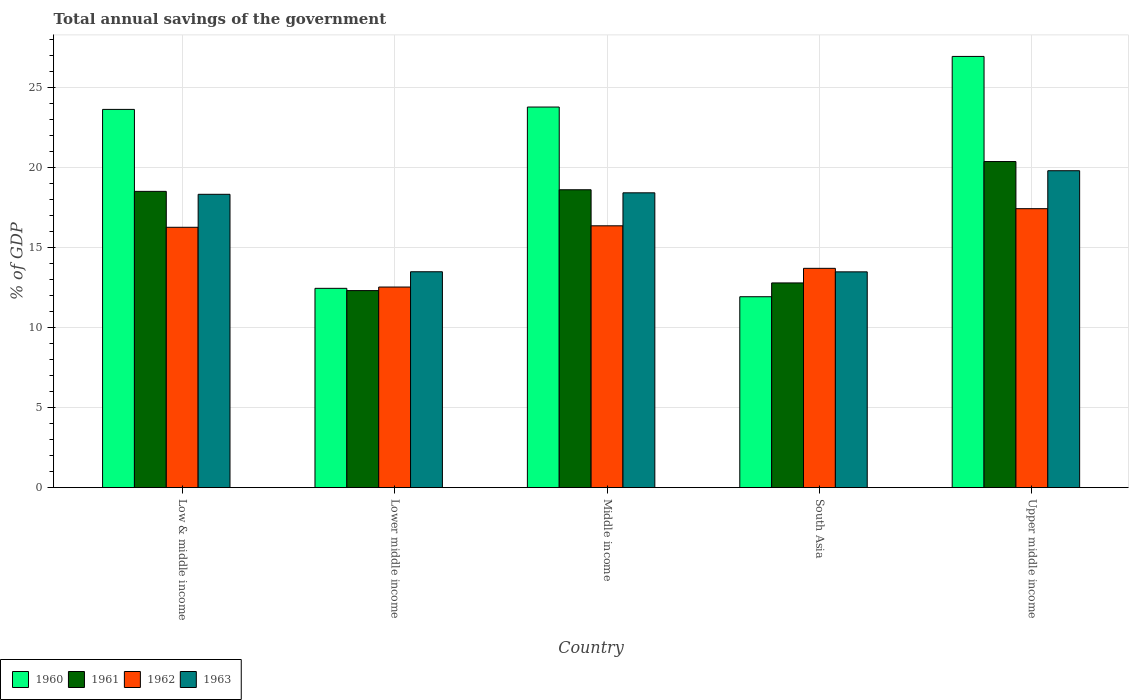How many different coloured bars are there?
Make the answer very short. 4. How many groups of bars are there?
Your response must be concise. 5. How many bars are there on the 4th tick from the left?
Make the answer very short. 4. How many bars are there on the 1st tick from the right?
Keep it short and to the point. 4. What is the label of the 3rd group of bars from the left?
Your response must be concise. Middle income. In how many cases, is the number of bars for a given country not equal to the number of legend labels?
Keep it short and to the point. 0. What is the total annual savings of the government in 1962 in Lower middle income?
Offer a very short reply. 12.53. Across all countries, what is the maximum total annual savings of the government in 1961?
Provide a short and direct response. 20.37. Across all countries, what is the minimum total annual savings of the government in 1961?
Offer a terse response. 12.3. In which country was the total annual savings of the government in 1962 maximum?
Your answer should be compact. Upper middle income. What is the total total annual savings of the government in 1962 in the graph?
Your answer should be compact. 76.25. What is the difference between the total annual savings of the government in 1960 in Low & middle income and that in South Asia?
Your answer should be very brief. 11.7. What is the difference between the total annual savings of the government in 1963 in South Asia and the total annual savings of the government in 1960 in Middle income?
Keep it short and to the point. -10.29. What is the average total annual savings of the government in 1960 per country?
Ensure brevity in your answer.  19.74. What is the difference between the total annual savings of the government of/in 1961 and total annual savings of the government of/in 1963 in Low & middle income?
Make the answer very short. 0.18. What is the ratio of the total annual savings of the government in 1962 in Middle income to that in Upper middle income?
Give a very brief answer. 0.94. Is the difference between the total annual savings of the government in 1961 in Lower middle income and Upper middle income greater than the difference between the total annual savings of the government in 1963 in Lower middle income and Upper middle income?
Give a very brief answer. No. What is the difference between the highest and the second highest total annual savings of the government in 1962?
Make the answer very short. -1.07. What is the difference between the highest and the lowest total annual savings of the government in 1962?
Offer a terse response. 4.89. In how many countries, is the total annual savings of the government in 1960 greater than the average total annual savings of the government in 1960 taken over all countries?
Your answer should be compact. 3. Is the sum of the total annual savings of the government in 1961 in Low & middle income and Upper middle income greater than the maximum total annual savings of the government in 1960 across all countries?
Your response must be concise. Yes. What does the 4th bar from the left in Low & middle income represents?
Provide a succinct answer. 1963. Is it the case that in every country, the sum of the total annual savings of the government in 1960 and total annual savings of the government in 1963 is greater than the total annual savings of the government in 1961?
Ensure brevity in your answer.  Yes. Are all the bars in the graph horizontal?
Your answer should be compact. No. Does the graph contain any zero values?
Keep it short and to the point. No. Does the graph contain grids?
Offer a terse response. Yes. What is the title of the graph?
Provide a succinct answer. Total annual savings of the government. Does "2011" appear as one of the legend labels in the graph?
Provide a succinct answer. No. What is the label or title of the X-axis?
Keep it short and to the point. Country. What is the label or title of the Y-axis?
Your answer should be compact. % of GDP. What is the % of GDP of 1960 in Low & middle income?
Give a very brief answer. 23.62. What is the % of GDP in 1961 in Low & middle income?
Your answer should be very brief. 18.5. What is the % of GDP in 1962 in Low & middle income?
Keep it short and to the point. 16.26. What is the % of GDP in 1963 in Low & middle income?
Your answer should be compact. 18.32. What is the % of GDP of 1960 in Lower middle income?
Ensure brevity in your answer.  12.45. What is the % of GDP in 1961 in Lower middle income?
Ensure brevity in your answer.  12.3. What is the % of GDP in 1962 in Lower middle income?
Keep it short and to the point. 12.53. What is the % of GDP of 1963 in Lower middle income?
Your response must be concise. 13.48. What is the % of GDP in 1960 in Middle income?
Ensure brevity in your answer.  23.77. What is the % of GDP in 1961 in Middle income?
Provide a short and direct response. 18.6. What is the % of GDP of 1962 in Middle income?
Give a very brief answer. 16.35. What is the % of GDP in 1963 in Middle income?
Provide a short and direct response. 18.41. What is the % of GDP in 1960 in South Asia?
Your answer should be compact. 11.92. What is the % of GDP of 1961 in South Asia?
Provide a short and direct response. 12.78. What is the % of GDP in 1962 in South Asia?
Keep it short and to the point. 13.69. What is the % of GDP of 1963 in South Asia?
Your response must be concise. 13.48. What is the % of GDP of 1960 in Upper middle income?
Ensure brevity in your answer.  26.93. What is the % of GDP in 1961 in Upper middle income?
Offer a very short reply. 20.37. What is the % of GDP of 1962 in Upper middle income?
Your answer should be very brief. 17.42. What is the % of GDP of 1963 in Upper middle income?
Provide a short and direct response. 19.79. Across all countries, what is the maximum % of GDP in 1960?
Your answer should be very brief. 26.93. Across all countries, what is the maximum % of GDP of 1961?
Provide a succinct answer. 20.37. Across all countries, what is the maximum % of GDP in 1962?
Provide a succinct answer. 17.42. Across all countries, what is the maximum % of GDP of 1963?
Offer a very short reply. 19.79. Across all countries, what is the minimum % of GDP in 1960?
Ensure brevity in your answer.  11.92. Across all countries, what is the minimum % of GDP of 1961?
Offer a terse response. 12.3. Across all countries, what is the minimum % of GDP of 1962?
Offer a terse response. 12.53. Across all countries, what is the minimum % of GDP of 1963?
Give a very brief answer. 13.48. What is the total % of GDP of 1960 in the graph?
Offer a terse response. 98.69. What is the total % of GDP of 1961 in the graph?
Give a very brief answer. 82.56. What is the total % of GDP in 1962 in the graph?
Offer a terse response. 76.25. What is the total % of GDP in 1963 in the graph?
Give a very brief answer. 83.48. What is the difference between the % of GDP in 1960 in Low & middle income and that in Lower middle income?
Offer a very short reply. 11.18. What is the difference between the % of GDP in 1961 in Low & middle income and that in Lower middle income?
Ensure brevity in your answer.  6.2. What is the difference between the % of GDP in 1962 in Low & middle income and that in Lower middle income?
Your answer should be very brief. 3.73. What is the difference between the % of GDP in 1963 in Low & middle income and that in Lower middle income?
Your response must be concise. 4.84. What is the difference between the % of GDP of 1960 in Low & middle income and that in Middle income?
Your answer should be very brief. -0.15. What is the difference between the % of GDP in 1961 in Low & middle income and that in Middle income?
Your response must be concise. -0.1. What is the difference between the % of GDP of 1962 in Low & middle income and that in Middle income?
Ensure brevity in your answer.  -0.09. What is the difference between the % of GDP of 1963 in Low & middle income and that in Middle income?
Ensure brevity in your answer.  -0.09. What is the difference between the % of GDP in 1960 in Low & middle income and that in South Asia?
Make the answer very short. 11.7. What is the difference between the % of GDP of 1961 in Low & middle income and that in South Asia?
Offer a very short reply. 5.72. What is the difference between the % of GDP in 1962 in Low & middle income and that in South Asia?
Give a very brief answer. 2.56. What is the difference between the % of GDP of 1963 in Low & middle income and that in South Asia?
Your response must be concise. 4.84. What is the difference between the % of GDP of 1960 in Low & middle income and that in Upper middle income?
Your answer should be very brief. -3.31. What is the difference between the % of GDP in 1961 in Low & middle income and that in Upper middle income?
Give a very brief answer. -1.86. What is the difference between the % of GDP of 1962 in Low & middle income and that in Upper middle income?
Keep it short and to the point. -1.16. What is the difference between the % of GDP in 1963 in Low & middle income and that in Upper middle income?
Ensure brevity in your answer.  -1.47. What is the difference between the % of GDP in 1960 in Lower middle income and that in Middle income?
Offer a very short reply. -11.32. What is the difference between the % of GDP of 1961 in Lower middle income and that in Middle income?
Give a very brief answer. -6.3. What is the difference between the % of GDP in 1962 in Lower middle income and that in Middle income?
Your response must be concise. -3.82. What is the difference between the % of GDP of 1963 in Lower middle income and that in Middle income?
Offer a very short reply. -4.93. What is the difference between the % of GDP of 1960 in Lower middle income and that in South Asia?
Your response must be concise. 0.52. What is the difference between the % of GDP in 1961 in Lower middle income and that in South Asia?
Provide a succinct answer. -0.48. What is the difference between the % of GDP of 1962 in Lower middle income and that in South Asia?
Provide a short and direct response. -1.17. What is the difference between the % of GDP in 1963 in Lower middle income and that in South Asia?
Keep it short and to the point. 0.01. What is the difference between the % of GDP of 1960 in Lower middle income and that in Upper middle income?
Ensure brevity in your answer.  -14.48. What is the difference between the % of GDP of 1961 in Lower middle income and that in Upper middle income?
Give a very brief answer. -8.06. What is the difference between the % of GDP in 1962 in Lower middle income and that in Upper middle income?
Make the answer very short. -4.89. What is the difference between the % of GDP in 1963 in Lower middle income and that in Upper middle income?
Make the answer very short. -6.31. What is the difference between the % of GDP in 1960 in Middle income and that in South Asia?
Offer a terse response. 11.85. What is the difference between the % of GDP in 1961 in Middle income and that in South Asia?
Provide a short and direct response. 5.82. What is the difference between the % of GDP of 1962 in Middle income and that in South Asia?
Keep it short and to the point. 2.66. What is the difference between the % of GDP of 1963 in Middle income and that in South Asia?
Ensure brevity in your answer.  4.94. What is the difference between the % of GDP of 1960 in Middle income and that in Upper middle income?
Keep it short and to the point. -3.16. What is the difference between the % of GDP of 1961 in Middle income and that in Upper middle income?
Your answer should be compact. -1.76. What is the difference between the % of GDP in 1962 in Middle income and that in Upper middle income?
Provide a succinct answer. -1.07. What is the difference between the % of GDP in 1963 in Middle income and that in Upper middle income?
Provide a short and direct response. -1.38. What is the difference between the % of GDP in 1960 in South Asia and that in Upper middle income?
Your answer should be very brief. -15.01. What is the difference between the % of GDP of 1961 in South Asia and that in Upper middle income?
Provide a succinct answer. -7.58. What is the difference between the % of GDP in 1962 in South Asia and that in Upper middle income?
Keep it short and to the point. -3.73. What is the difference between the % of GDP in 1963 in South Asia and that in Upper middle income?
Offer a very short reply. -6.32. What is the difference between the % of GDP of 1960 in Low & middle income and the % of GDP of 1961 in Lower middle income?
Your answer should be very brief. 11.32. What is the difference between the % of GDP of 1960 in Low & middle income and the % of GDP of 1962 in Lower middle income?
Provide a short and direct response. 11.09. What is the difference between the % of GDP of 1960 in Low & middle income and the % of GDP of 1963 in Lower middle income?
Keep it short and to the point. 10.14. What is the difference between the % of GDP in 1961 in Low & middle income and the % of GDP in 1962 in Lower middle income?
Provide a succinct answer. 5.97. What is the difference between the % of GDP in 1961 in Low & middle income and the % of GDP in 1963 in Lower middle income?
Make the answer very short. 5.02. What is the difference between the % of GDP of 1962 in Low & middle income and the % of GDP of 1963 in Lower middle income?
Provide a short and direct response. 2.78. What is the difference between the % of GDP of 1960 in Low & middle income and the % of GDP of 1961 in Middle income?
Make the answer very short. 5.02. What is the difference between the % of GDP in 1960 in Low & middle income and the % of GDP in 1962 in Middle income?
Your answer should be very brief. 7.27. What is the difference between the % of GDP of 1960 in Low & middle income and the % of GDP of 1963 in Middle income?
Provide a short and direct response. 5.21. What is the difference between the % of GDP of 1961 in Low & middle income and the % of GDP of 1962 in Middle income?
Ensure brevity in your answer.  2.15. What is the difference between the % of GDP of 1961 in Low & middle income and the % of GDP of 1963 in Middle income?
Give a very brief answer. 0.09. What is the difference between the % of GDP in 1962 in Low & middle income and the % of GDP in 1963 in Middle income?
Your answer should be compact. -2.15. What is the difference between the % of GDP in 1960 in Low & middle income and the % of GDP in 1961 in South Asia?
Your response must be concise. 10.84. What is the difference between the % of GDP of 1960 in Low & middle income and the % of GDP of 1962 in South Asia?
Your answer should be compact. 9.93. What is the difference between the % of GDP in 1960 in Low & middle income and the % of GDP in 1963 in South Asia?
Your answer should be compact. 10.15. What is the difference between the % of GDP of 1961 in Low & middle income and the % of GDP of 1962 in South Asia?
Your response must be concise. 4.81. What is the difference between the % of GDP of 1961 in Low & middle income and the % of GDP of 1963 in South Asia?
Your answer should be very brief. 5.03. What is the difference between the % of GDP in 1962 in Low & middle income and the % of GDP in 1963 in South Asia?
Your answer should be compact. 2.78. What is the difference between the % of GDP of 1960 in Low & middle income and the % of GDP of 1961 in Upper middle income?
Your answer should be compact. 3.26. What is the difference between the % of GDP in 1960 in Low & middle income and the % of GDP in 1962 in Upper middle income?
Make the answer very short. 6.2. What is the difference between the % of GDP of 1960 in Low & middle income and the % of GDP of 1963 in Upper middle income?
Your answer should be very brief. 3.83. What is the difference between the % of GDP of 1961 in Low & middle income and the % of GDP of 1962 in Upper middle income?
Give a very brief answer. 1.08. What is the difference between the % of GDP in 1961 in Low & middle income and the % of GDP in 1963 in Upper middle income?
Provide a short and direct response. -1.29. What is the difference between the % of GDP in 1962 in Low & middle income and the % of GDP in 1963 in Upper middle income?
Ensure brevity in your answer.  -3.53. What is the difference between the % of GDP of 1960 in Lower middle income and the % of GDP of 1961 in Middle income?
Provide a succinct answer. -6.16. What is the difference between the % of GDP in 1960 in Lower middle income and the % of GDP in 1962 in Middle income?
Keep it short and to the point. -3.9. What is the difference between the % of GDP in 1960 in Lower middle income and the % of GDP in 1963 in Middle income?
Your answer should be very brief. -5.97. What is the difference between the % of GDP of 1961 in Lower middle income and the % of GDP of 1962 in Middle income?
Keep it short and to the point. -4.05. What is the difference between the % of GDP in 1961 in Lower middle income and the % of GDP in 1963 in Middle income?
Your answer should be very brief. -6.11. What is the difference between the % of GDP in 1962 in Lower middle income and the % of GDP in 1963 in Middle income?
Keep it short and to the point. -5.88. What is the difference between the % of GDP of 1960 in Lower middle income and the % of GDP of 1961 in South Asia?
Provide a short and direct response. -0.34. What is the difference between the % of GDP in 1960 in Lower middle income and the % of GDP in 1962 in South Asia?
Ensure brevity in your answer.  -1.25. What is the difference between the % of GDP of 1960 in Lower middle income and the % of GDP of 1963 in South Asia?
Provide a succinct answer. -1.03. What is the difference between the % of GDP of 1961 in Lower middle income and the % of GDP of 1962 in South Asia?
Provide a short and direct response. -1.39. What is the difference between the % of GDP of 1961 in Lower middle income and the % of GDP of 1963 in South Asia?
Give a very brief answer. -1.17. What is the difference between the % of GDP in 1962 in Lower middle income and the % of GDP in 1963 in South Asia?
Offer a very short reply. -0.95. What is the difference between the % of GDP of 1960 in Lower middle income and the % of GDP of 1961 in Upper middle income?
Provide a short and direct response. -7.92. What is the difference between the % of GDP of 1960 in Lower middle income and the % of GDP of 1962 in Upper middle income?
Offer a very short reply. -4.98. What is the difference between the % of GDP in 1960 in Lower middle income and the % of GDP in 1963 in Upper middle income?
Offer a very short reply. -7.35. What is the difference between the % of GDP in 1961 in Lower middle income and the % of GDP in 1962 in Upper middle income?
Give a very brief answer. -5.12. What is the difference between the % of GDP in 1961 in Lower middle income and the % of GDP in 1963 in Upper middle income?
Make the answer very short. -7.49. What is the difference between the % of GDP of 1962 in Lower middle income and the % of GDP of 1963 in Upper middle income?
Make the answer very short. -7.26. What is the difference between the % of GDP in 1960 in Middle income and the % of GDP in 1961 in South Asia?
Provide a succinct answer. 10.98. What is the difference between the % of GDP in 1960 in Middle income and the % of GDP in 1962 in South Asia?
Your answer should be very brief. 10.07. What is the difference between the % of GDP of 1960 in Middle income and the % of GDP of 1963 in South Asia?
Make the answer very short. 10.29. What is the difference between the % of GDP in 1961 in Middle income and the % of GDP in 1962 in South Asia?
Keep it short and to the point. 4.91. What is the difference between the % of GDP in 1961 in Middle income and the % of GDP in 1963 in South Asia?
Make the answer very short. 5.13. What is the difference between the % of GDP of 1962 in Middle income and the % of GDP of 1963 in South Asia?
Give a very brief answer. 2.88. What is the difference between the % of GDP of 1960 in Middle income and the % of GDP of 1961 in Upper middle income?
Make the answer very short. 3.4. What is the difference between the % of GDP of 1960 in Middle income and the % of GDP of 1962 in Upper middle income?
Make the answer very short. 6.35. What is the difference between the % of GDP of 1960 in Middle income and the % of GDP of 1963 in Upper middle income?
Your answer should be very brief. 3.98. What is the difference between the % of GDP in 1961 in Middle income and the % of GDP in 1962 in Upper middle income?
Your answer should be compact. 1.18. What is the difference between the % of GDP of 1961 in Middle income and the % of GDP of 1963 in Upper middle income?
Offer a terse response. -1.19. What is the difference between the % of GDP of 1962 in Middle income and the % of GDP of 1963 in Upper middle income?
Ensure brevity in your answer.  -3.44. What is the difference between the % of GDP in 1960 in South Asia and the % of GDP in 1961 in Upper middle income?
Make the answer very short. -8.44. What is the difference between the % of GDP of 1960 in South Asia and the % of GDP of 1962 in Upper middle income?
Your answer should be compact. -5.5. What is the difference between the % of GDP of 1960 in South Asia and the % of GDP of 1963 in Upper middle income?
Offer a very short reply. -7.87. What is the difference between the % of GDP in 1961 in South Asia and the % of GDP in 1962 in Upper middle income?
Your answer should be very brief. -4.64. What is the difference between the % of GDP of 1961 in South Asia and the % of GDP of 1963 in Upper middle income?
Ensure brevity in your answer.  -7.01. What is the difference between the % of GDP of 1962 in South Asia and the % of GDP of 1963 in Upper middle income?
Your answer should be very brief. -6.1. What is the average % of GDP in 1960 per country?
Make the answer very short. 19.74. What is the average % of GDP of 1961 per country?
Keep it short and to the point. 16.51. What is the average % of GDP of 1962 per country?
Your answer should be compact. 15.25. What is the average % of GDP of 1963 per country?
Your response must be concise. 16.7. What is the difference between the % of GDP of 1960 and % of GDP of 1961 in Low & middle income?
Provide a succinct answer. 5.12. What is the difference between the % of GDP of 1960 and % of GDP of 1962 in Low & middle income?
Offer a terse response. 7.36. What is the difference between the % of GDP of 1960 and % of GDP of 1963 in Low & middle income?
Your answer should be very brief. 5.3. What is the difference between the % of GDP in 1961 and % of GDP in 1962 in Low & middle income?
Your response must be concise. 2.24. What is the difference between the % of GDP in 1961 and % of GDP in 1963 in Low & middle income?
Your answer should be very brief. 0.18. What is the difference between the % of GDP in 1962 and % of GDP in 1963 in Low & middle income?
Provide a succinct answer. -2.06. What is the difference between the % of GDP in 1960 and % of GDP in 1961 in Lower middle income?
Offer a terse response. 0.14. What is the difference between the % of GDP in 1960 and % of GDP in 1962 in Lower middle income?
Your answer should be compact. -0.08. What is the difference between the % of GDP in 1960 and % of GDP in 1963 in Lower middle income?
Offer a very short reply. -1.04. What is the difference between the % of GDP in 1961 and % of GDP in 1962 in Lower middle income?
Your response must be concise. -0.22. What is the difference between the % of GDP in 1961 and % of GDP in 1963 in Lower middle income?
Ensure brevity in your answer.  -1.18. What is the difference between the % of GDP in 1962 and % of GDP in 1963 in Lower middle income?
Your answer should be very brief. -0.95. What is the difference between the % of GDP in 1960 and % of GDP in 1961 in Middle income?
Your answer should be compact. 5.17. What is the difference between the % of GDP of 1960 and % of GDP of 1962 in Middle income?
Keep it short and to the point. 7.42. What is the difference between the % of GDP of 1960 and % of GDP of 1963 in Middle income?
Ensure brevity in your answer.  5.36. What is the difference between the % of GDP in 1961 and % of GDP in 1962 in Middle income?
Make the answer very short. 2.25. What is the difference between the % of GDP in 1961 and % of GDP in 1963 in Middle income?
Ensure brevity in your answer.  0.19. What is the difference between the % of GDP of 1962 and % of GDP of 1963 in Middle income?
Ensure brevity in your answer.  -2.06. What is the difference between the % of GDP in 1960 and % of GDP in 1961 in South Asia?
Provide a succinct answer. -0.86. What is the difference between the % of GDP of 1960 and % of GDP of 1962 in South Asia?
Make the answer very short. -1.77. What is the difference between the % of GDP in 1960 and % of GDP in 1963 in South Asia?
Keep it short and to the point. -1.55. What is the difference between the % of GDP in 1961 and % of GDP in 1962 in South Asia?
Your response must be concise. -0.91. What is the difference between the % of GDP in 1961 and % of GDP in 1963 in South Asia?
Offer a very short reply. -0.69. What is the difference between the % of GDP of 1962 and % of GDP of 1963 in South Asia?
Ensure brevity in your answer.  0.22. What is the difference between the % of GDP in 1960 and % of GDP in 1961 in Upper middle income?
Provide a succinct answer. 6.56. What is the difference between the % of GDP of 1960 and % of GDP of 1962 in Upper middle income?
Give a very brief answer. 9.51. What is the difference between the % of GDP of 1960 and % of GDP of 1963 in Upper middle income?
Offer a terse response. 7.14. What is the difference between the % of GDP in 1961 and % of GDP in 1962 in Upper middle income?
Ensure brevity in your answer.  2.94. What is the difference between the % of GDP in 1961 and % of GDP in 1963 in Upper middle income?
Offer a very short reply. 0.57. What is the difference between the % of GDP of 1962 and % of GDP of 1963 in Upper middle income?
Offer a very short reply. -2.37. What is the ratio of the % of GDP of 1960 in Low & middle income to that in Lower middle income?
Keep it short and to the point. 1.9. What is the ratio of the % of GDP of 1961 in Low & middle income to that in Lower middle income?
Ensure brevity in your answer.  1.5. What is the ratio of the % of GDP in 1962 in Low & middle income to that in Lower middle income?
Make the answer very short. 1.3. What is the ratio of the % of GDP in 1963 in Low & middle income to that in Lower middle income?
Your answer should be compact. 1.36. What is the ratio of the % of GDP of 1961 in Low & middle income to that in Middle income?
Offer a terse response. 0.99. What is the ratio of the % of GDP of 1960 in Low & middle income to that in South Asia?
Your response must be concise. 1.98. What is the ratio of the % of GDP of 1961 in Low & middle income to that in South Asia?
Offer a terse response. 1.45. What is the ratio of the % of GDP in 1962 in Low & middle income to that in South Asia?
Offer a very short reply. 1.19. What is the ratio of the % of GDP of 1963 in Low & middle income to that in South Asia?
Provide a short and direct response. 1.36. What is the ratio of the % of GDP of 1960 in Low & middle income to that in Upper middle income?
Give a very brief answer. 0.88. What is the ratio of the % of GDP in 1961 in Low & middle income to that in Upper middle income?
Offer a very short reply. 0.91. What is the ratio of the % of GDP of 1962 in Low & middle income to that in Upper middle income?
Offer a terse response. 0.93. What is the ratio of the % of GDP of 1963 in Low & middle income to that in Upper middle income?
Give a very brief answer. 0.93. What is the ratio of the % of GDP in 1960 in Lower middle income to that in Middle income?
Make the answer very short. 0.52. What is the ratio of the % of GDP in 1961 in Lower middle income to that in Middle income?
Your response must be concise. 0.66. What is the ratio of the % of GDP of 1962 in Lower middle income to that in Middle income?
Your answer should be compact. 0.77. What is the ratio of the % of GDP of 1963 in Lower middle income to that in Middle income?
Provide a short and direct response. 0.73. What is the ratio of the % of GDP of 1960 in Lower middle income to that in South Asia?
Your answer should be very brief. 1.04. What is the ratio of the % of GDP of 1961 in Lower middle income to that in South Asia?
Ensure brevity in your answer.  0.96. What is the ratio of the % of GDP in 1962 in Lower middle income to that in South Asia?
Provide a succinct answer. 0.91. What is the ratio of the % of GDP of 1963 in Lower middle income to that in South Asia?
Give a very brief answer. 1. What is the ratio of the % of GDP in 1960 in Lower middle income to that in Upper middle income?
Provide a succinct answer. 0.46. What is the ratio of the % of GDP in 1961 in Lower middle income to that in Upper middle income?
Ensure brevity in your answer.  0.6. What is the ratio of the % of GDP of 1962 in Lower middle income to that in Upper middle income?
Provide a short and direct response. 0.72. What is the ratio of the % of GDP of 1963 in Lower middle income to that in Upper middle income?
Provide a succinct answer. 0.68. What is the ratio of the % of GDP of 1960 in Middle income to that in South Asia?
Make the answer very short. 1.99. What is the ratio of the % of GDP of 1961 in Middle income to that in South Asia?
Your answer should be compact. 1.46. What is the ratio of the % of GDP of 1962 in Middle income to that in South Asia?
Your answer should be compact. 1.19. What is the ratio of the % of GDP in 1963 in Middle income to that in South Asia?
Offer a terse response. 1.37. What is the ratio of the % of GDP of 1960 in Middle income to that in Upper middle income?
Ensure brevity in your answer.  0.88. What is the ratio of the % of GDP of 1961 in Middle income to that in Upper middle income?
Offer a terse response. 0.91. What is the ratio of the % of GDP of 1962 in Middle income to that in Upper middle income?
Your answer should be compact. 0.94. What is the ratio of the % of GDP in 1963 in Middle income to that in Upper middle income?
Offer a terse response. 0.93. What is the ratio of the % of GDP in 1960 in South Asia to that in Upper middle income?
Keep it short and to the point. 0.44. What is the ratio of the % of GDP of 1961 in South Asia to that in Upper middle income?
Your response must be concise. 0.63. What is the ratio of the % of GDP in 1962 in South Asia to that in Upper middle income?
Your answer should be very brief. 0.79. What is the ratio of the % of GDP of 1963 in South Asia to that in Upper middle income?
Provide a short and direct response. 0.68. What is the difference between the highest and the second highest % of GDP of 1960?
Give a very brief answer. 3.16. What is the difference between the highest and the second highest % of GDP in 1961?
Your answer should be compact. 1.76. What is the difference between the highest and the second highest % of GDP in 1962?
Your response must be concise. 1.07. What is the difference between the highest and the second highest % of GDP in 1963?
Your answer should be very brief. 1.38. What is the difference between the highest and the lowest % of GDP in 1960?
Keep it short and to the point. 15.01. What is the difference between the highest and the lowest % of GDP in 1961?
Offer a very short reply. 8.06. What is the difference between the highest and the lowest % of GDP of 1962?
Provide a succinct answer. 4.89. What is the difference between the highest and the lowest % of GDP in 1963?
Make the answer very short. 6.32. 